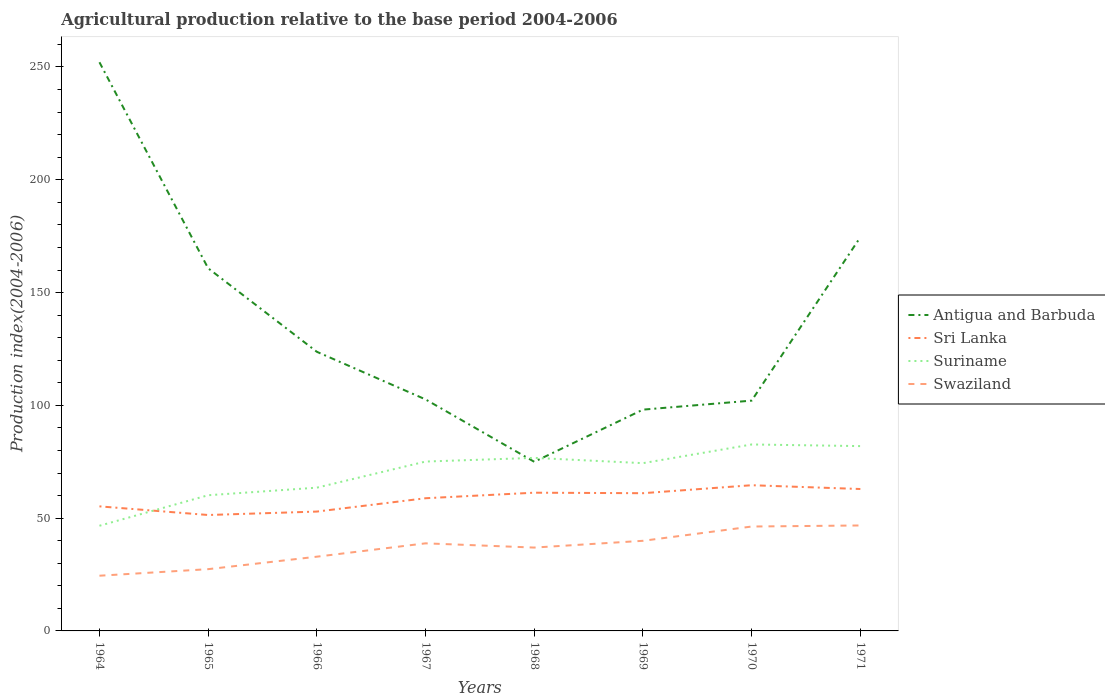Does the line corresponding to Antigua and Barbuda intersect with the line corresponding to Swaziland?
Offer a very short reply. No. Across all years, what is the maximum agricultural production index in Swaziland?
Ensure brevity in your answer.  24.47. In which year was the agricultural production index in Swaziland maximum?
Make the answer very short. 1964. What is the total agricultural production index in Swaziland in the graph?
Provide a succinct answer. -8.44. What is the difference between the highest and the second highest agricultural production index in Sri Lanka?
Make the answer very short. 13.2. What is the difference between the highest and the lowest agricultural production index in Swaziland?
Provide a short and direct response. 5. How many years are there in the graph?
Your answer should be compact. 8. What is the difference between two consecutive major ticks on the Y-axis?
Offer a terse response. 50. Are the values on the major ticks of Y-axis written in scientific E-notation?
Keep it short and to the point. No. Does the graph contain grids?
Your answer should be very brief. No. How many legend labels are there?
Give a very brief answer. 4. What is the title of the graph?
Ensure brevity in your answer.  Agricultural production relative to the base period 2004-2006. Does "Seychelles" appear as one of the legend labels in the graph?
Provide a short and direct response. No. What is the label or title of the X-axis?
Provide a succinct answer. Years. What is the label or title of the Y-axis?
Offer a very short reply. Production index(2004-2006). What is the Production index(2004-2006) of Antigua and Barbuda in 1964?
Keep it short and to the point. 252.1. What is the Production index(2004-2006) of Sri Lanka in 1964?
Your answer should be very brief. 55.22. What is the Production index(2004-2006) in Suriname in 1964?
Keep it short and to the point. 46.62. What is the Production index(2004-2006) of Swaziland in 1964?
Give a very brief answer. 24.47. What is the Production index(2004-2006) in Antigua and Barbuda in 1965?
Offer a terse response. 160.77. What is the Production index(2004-2006) of Sri Lanka in 1965?
Provide a short and direct response. 51.39. What is the Production index(2004-2006) of Suriname in 1965?
Keep it short and to the point. 60.15. What is the Production index(2004-2006) in Swaziland in 1965?
Your answer should be compact. 27.38. What is the Production index(2004-2006) in Antigua and Barbuda in 1966?
Your answer should be compact. 123.74. What is the Production index(2004-2006) in Sri Lanka in 1966?
Your response must be concise. 52.91. What is the Production index(2004-2006) in Suriname in 1966?
Ensure brevity in your answer.  63.51. What is the Production index(2004-2006) of Swaziland in 1966?
Provide a short and direct response. 32.91. What is the Production index(2004-2006) in Antigua and Barbuda in 1967?
Keep it short and to the point. 102.63. What is the Production index(2004-2006) in Sri Lanka in 1967?
Ensure brevity in your answer.  58.82. What is the Production index(2004-2006) in Suriname in 1967?
Your answer should be compact. 75.08. What is the Production index(2004-2006) of Swaziland in 1967?
Offer a terse response. 38.83. What is the Production index(2004-2006) of Antigua and Barbuda in 1968?
Make the answer very short. 74.98. What is the Production index(2004-2006) of Sri Lanka in 1968?
Ensure brevity in your answer.  61.28. What is the Production index(2004-2006) in Suriname in 1968?
Offer a terse response. 76.72. What is the Production index(2004-2006) in Swaziland in 1968?
Provide a short and direct response. 36.95. What is the Production index(2004-2006) of Antigua and Barbuda in 1969?
Provide a succinct answer. 98.1. What is the Production index(2004-2006) of Sri Lanka in 1969?
Offer a terse response. 61.05. What is the Production index(2004-2006) in Suriname in 1969?
Offer a terse response. 74.37. What is the Production index(2004-2006) of Swaziland in 1969?
Provide a short and direct response. 39.95. What is the Production index(2004-2006) of Antigua and Barbuda in 1970?
Provide a succinct answer. 102.1. What is the Production index(2004-2006) of Sri Lanka in 1970?
Give a very brief answer. 64.59. What is the Production index(2004-2006) in Suriname in 1970?
Provide a succinct answer. 82.66. What is the Production index(2004-2006) in Swaziland in 1970?
Keep it short and to the point. 46.28. What is the Production index(2004-2006) in Antigua and Barbuda in 1971?
Ensure brevity in your answer.  174.55. What is the Production index(2004-2006) of Sri Lanka in 1971?
Offer a terse response. 62.91. What is the Production index(2004-2006) in Suriname in 1971?
Your answer should be very brief. 81.93. What is the Production index(2004-2006) in Swaziland in 1971?
Offer a very short reply. 46.75. Across all years, what is the maximum Production index(2004-2006) in Antigua and Barbuda?
Your response must be concise. 252.1. Across all years, what is the maximum Production index(2004-2006) of Sri Lanka?
Provide a succinct answer. 64.59. Across all years, what is the maximum Production index(2004-2006) of Suriname?
Your answer should be compact. 82.66. Across all years, what is the maximum Production index(2004-2006) in Swaziland?
Ensure brevity in your answer.  46.75. Across all years, what is the minimum Production index(2004-2006) of Antigua and Barbuda?
Make the answer very short. 74.98. Across all years, what is the minimum Production index(2004-2006) in Sri Lanka?
Offer a very short reply. 51.39. Across all years, what is the minimum Production index(2004-2006) in Suriname?
Provide a succinct answer. 46.62. Across all years, what is the minimum Production index(2004-2006) of Swaziland?
Offer a very short reply. 24.47. What is the total Production index(2004-2006) of Antigua and Barbuda in the graph?
Ensure brevity in your answer.  1088.97. What is the total Production index(2004-2006) in Sri Lanka in the graph?
Make the answer very short. 468.17. What is the total Production index(2004-2006) in Suriname in the graph?
Make the answer very short. 561.04. What is the total Production index(2004-2006) in Swaziland in the graph?
Your response must be concise. 293.52. What is the difference between the Production index(2004-2006) in Antigua and Barbuda in 1964 and that in 1965?
Give a very brief answer. 91.33. What is the difference between the Production index(2004-2006) of Sri Lanka in 1964 and that in 1965?
Keep it short and to the point. 3.83. What is the difference between the Production index(2004-2006) in Suriname in 1964 and that in 1965?
Provide a succinct answer. -13.53. What is the difference between the Production index(2004-2006) in Swaziland in 1964 and that in 1965?
Your answer should be very brief. -2.91. What is the difference between the Production index(2004-2006) of Antigua and Barbuda in 1964 and that in 1966?
Keep it short and to the point. 128.36. What is the difference between the Production index(2004-2006) in Sri Lanka in 1964 and that in 1966?
Offer a terse response. 2.31. What is the difference between the Production index(2004-2006) in Suriname in 1964 and that in 1966?
Your answer should be compact. -16.89. What is the difference between the Production index(2004-2006) in Swaziland in 1964 and that in 1966?
Your answer should be very brief. -8.44. What is the difference between the Production index(2004-2006) in Antigua and Barbuda in 1964 and that in 1967?
Offer a terse response. 149.47. What is the difference between the Production index(2004-2006) of Sri Lanka in 1964 and that in 1967?
Keep it short and to the point. -3.6. What is the difference between the Production index(2004-2006) of Suriname in 1964 and that in 1967?
Make the answer very short. -28.46. What is the difference between the Production index(2004-2006) of Swaziland in 1964 and that in 1967?
Ensure brevity in your answer.  -14.36. What is the difference between the Production index(2004-2006) in Antigua and Barbuda in 1964 and that in 1968?
Offer a terse response. 177.12. What is the difference between the Production index(2004-2006) of Sri Lanka in 1964 and that in 1968?
Give a very brief answer. -6.06. What is the difference between the Production index(2004-2006) of Suriname in 1964 and that in 1968?
Ensure brevity in your answer.  -30.1. What is the difference between the Production index(2004-2006) of Swaziland in 1964 and that in 1968?
Give a very brief answer. -12.48. What is the difference between the Production index(2004-2006) of Antigua and Barbuda in 1964 and that in 1969?
Keep it short and to the point. 154. What is the difference between the Production index(2004-2006) of Sri Lanka in 1964 and that in 1969?
Your response must be concise. -5.83. What is the difference between the Production index(2004-2006) of Suriname in 1964 and that in 1969?
Your response must be concise. -27.75. What is the difference between the Production index(2004-2006) in Swaziland in 1964 and that in 1969?
Offer a terse response. -15.48. What is the difference between the Production index(2004-2006) of Antigua and Barbuda in 1964 and that in 1970?
Provide a succinct answer. 150. What is the difference between the Production index(2004-2006) of Sri Lanka in 1964 and that in 1970?
Make the answer very short. -9.37. What is the difference between the Production index(2004-2006) in Suriname in 1964 and that in 1970?
Provide a short and direct response. -36.04. What is the difference between the Production index(2004-2006) in Swaziland in 1964 and that in 1970?
Make the answer very short. -21.81. What is the difference between the Production index(2004-2006) of Antigua and Barbuda in 1964 and that in 1971?
Give a very brief answer. 77.55. What is the difference between the Production index(2004-2006) in Sri Lanka in 1964 and that in 1971?
Offer a very short reply. -7.69. What is the difference between the Production index(2004-2006) in Suriname in 1964 and that in 1971?
Your answer should be compact. -35.31. What is the difference between the Production index(2004-2006) of Swaziland in 1964 and that in 1971?
Your response must be concise. -22.28. What is the difference between the Production index(2004-2006) of Antigua and Barbuda in 1965 and that in 1966?
Provide a short and direct response. 37.03. What is the difference between the Production index(2004-2006) in Sri Lanka in 1965 and that in 1966?
Give a very brief answer. -1.52. What is the difference between the Production index(2004-2006) of Suriname in 1965 and that in 1966?
Make the answer very short. -3.36. What is the difference between the Production index(2004-2006) of Swaziland in 1965 and that in 1966?
Keep it short and to the point. -5.53. What is the difference between the Production index(2004-2006) in Antigua and Barbuda in 1965 and that in 1967?
Provide a succinct answer. 58.14. What is the difference between the Production index(2004-2006) of Sri Lanka in 1965 and that in 1967?
Make the answer very short. -7.43. What is the difference between the Production index(2004-2006) in Suriname in 1965 and that in 1967?
Offer a very short reply. -14.93. What is the difference between the Production index(2004-2006) in Swaziland in 1965 and that in 1967?
Make the answer very short. -11.45. What is the difference between the Production index(2004-2006) in Antigua and Barbuda in 1965 and that in 1968?
Your answer should be compact. 85.79. What is the difference between the Production index(2004-2006) in Sri Lanka in 1965 and that in 1968?
Ensure brevity in your answer.  -9.89. What is the difference between the Production index(2004-2006) of Suriname in 1965 and that in 1968?
Make the answer very short. -16.57. What is the difference between the Production index(2004-2006) of Swaziland in 1965 and that in 1968?
Offer a very short reply. -9.57. What is the difference between the Production index(2004-2006) of Antigua and Barbuda in 1965 and that in 1969?
Give a very brief answer. 62.67. What is the difference between the Production index(2004-2006) in Sri Lanka in 1965 and that in 1969?
Your answer should be compact. -9.66. What is the difference between the Production index(2004-2006) in Suriname in 1965 and that in 1969?
Provide a short and direct response. -14.22. What is the difference between the Production index(2004-2006) of Swaziland in 1965 and that in 1969?
Your response must be concise. -12.57. What is the difference between the Production index(2004-2006) in Antigua and Barbuda in 1965 and that in 1970?
Ensure brevity in your answer.  58.67. What is the difference between the Production index(2004-2006) of Sri Lanka in 1965 and that in 1970?
Your answer should be compact. -13.2. What is the difference between the Production index(2004-2006) in Suriname in 1965 and that in 1970?
Your answer should be compact. -22.51. What is the difference between the Production index(2004-2006) of Swaziland in 1965 and that in 1970?
Offer a terse response. -18.9. What is the difference between the Production index(2004-2006) in Antigua and Barbuda in 1965 and that in 1971?
Your answer should be very brief. -13.78. What is the difference between the Production index(2004-2006) of Sri Lanka in 1965 and that in 1971?
Ensure brevity in your answer.  -11.52. What is the difference between the Production index(2004-2006) of Suriname in 1965 and that in 1971?
Offer a very short reply. -21.78. What is the difference between the Production index(2004-2006) of Swaziland in 1965 and that in 1971?
Your response must be concise. -19.37. What is the difference between the Production index(2004-2006) of Antigua and Barbuda in 1966 and that in 1967?
Provide a succinct answer. 21.11. What is the difference between the Production index(2004-2006) of Sri Lanka in 1966 and that in 1967?
Offer a terse response. -5.91. What is the difference between the Production index(2004-2006) of Suriname in 1966 and that in 1967?
Ensure brevity in your answer.  -11.57. What is the difference between the Production index(2004-2006) of Swaziland in 1966 and that in 1967?
Give a very brief answer. -5.92. What is the difference between the Production index(2004-2006) in Antigua and Barbuda in 1966 and that in 1968?
Your response must be concise. 48.76. What is the difference between the Production index(2004-2006) in Sri Lanka in 1966 and that in 1968?
Your answer should be compact. -8.37. What is the difference between the Production index(2004-2006) of Suriname in 1966 and that in 1968?
Make the answer very short. -13.21. What is the difference between the Production index(2004-2006) in Swaziland in 1966 and that in 1968?
Offer a very short reply. -4.04. What is the difference between the Production index(2004-2006) of Antigua and Barbuda in 1966 and that in 1969?
Offer a very short reply. 25.64. What is the difference between the Production index(2004-2006) in Sri Lanka in 1966 and that in 1969?
Make the answer very short. -8.14. What is the difference between the Production index(2004-2006) in Suriname in 1966 and that in 1969?
Provide a short and direct response. -10.86. What is the difference between the Production index(2004-2006) in Swaziland in 1966 and that in 1969?
Offer a terse response. -7.04. What is the difference between the Production index(2004-2006) of Antigua and Barbuda in 1966 and that in 1970?
Ensure brevity in your answer.  21.64. What is the difference between the Production index(2004-2006) in Sri Lanka in 1966 and that in 1970?
Give a very brief answer. -11.68. What is the difference between the Production index(2004-2006) in Suriname in 1966 and that in 1970?
Your answer should be compact. -19.15. What is the difference between the Production index(2004-2006) of Swaziland in 1966 and that in 1970?
Offer a terse response. -13.37. What is the difference between the Production index(2004-2006) of Antigua and Barbuda in 1966 and that in 1971?
Offer a very short reply. -50.81. What is the difference between the Production index(2004-2006) in Sri Lanka in 1966 and that in 1971?
Offer a terse response. -10. What is the difference between the Production index(2004-2006) of Suriname in 1966 and that in 1971?
Your response must be concise. -18.42. What is the difference between the Production index(2004-2006) of Swaziland in 1966 and that in 1971?
Make the answer very short. -13.84. What is the difference between the Production index(2004-2006) in Antigua and Barbuda in 1967 and that in 1968?
Ensure brevity in your answer.  27.65. What is the difference between the Production index(2004-2006) of Sri Lanka in 1967 and that in 1968?
Your answer should be very brief. -2.46. What is the difference between the Production index(2004-2006) of Suriname in 1967 and that in 1968?
Offer a terse response. -1.64. What is the difference between the Production index(2004-2006) of Swaziland in 1967 and that in 1968?
Ensure brevity in your answer.  1.88. What is the difference between the Production index(2004-2006) of Antigua and Barbuda in 1967 and that in 1969?
Your response must be concise. 4.53. What is the difference between the Production index(2004-2006) of Sri Lanka in 1967 and that in 1969?
Your answer should be very brief. -2.23. What is the difference between the Production index(2004-2006) in Suriname in 1967 and that in 1969?
Provide a succinct answer. 0.71. What is the difference between the Production index(2004-2006) in Swaziland in 1967 and that in 1969?
Keep it short and to the point. -1.12. What is the difference between the Production index(2004-2006) of Antigua and Barbuda in 1967 and that in 1970?
Make the answer very short. 0.53. What is the difference between the Production index(2004-2006) in Sri Lanka in 1967 and that in 1970?
Offer a terse response. -5.77. What is the difference between the Production index(2004-2006) of Suriname in 1967 and that in 1970?
Offer a terse response. -7.58. What is the difference between the Production index(2004-2006) in Swaziland in 1967 and that in 1970?
Offer a very short reply. -7.45. What is the difference between the Production index(2004-2006) in Antigua and Barbuda in 1967 and that in 1971?
Offer a very short reply. -71.92. What is the difference between the Production index(2004-2006) in Sri Lanka in 1967 and that in 1971?
Ensure brevity in your answer.  -4.09. What is the difference between the Production index(2004-2006) in Suriname in 1967 and that in 1971?
Your answer should be very brief. -6.85. What is the difference between the Production index(2004-2006) in Swaziland in 1967 and that in 1971?
Give a very brief answer. -7.92. What is the difference between the Production index(2004-2006) of Antigua and Barbuda in 1968 and that in 1969?
Provide a succinct answer. -23.12. What is the difference between the Production index(2004-2006) of Sri Lanka in 1968 and that in 1969?
Your answer should be very brief. 0.23. What is the difference between the Production index(2004-2006) in Suriname in 1968 and that in 1969?
Give a very brief answer. 2.35. What is the difference between the Production index(2004-2006) of Antigua and Barbuda in 1968 and that in 1970?
Your answer should be very brief. -27.12. What is the difference between the Production index(2004-2006) in Sri Lanka in 1968 and that in 1970?
Ensure brevity in your answer.  -3.31. What is the difference between the Production index(2004-2006) of Suriname in 1968 and that in 1970?
Your answer should be compact. -5.94. What is the difference between the Production index(2004-2006) of Swaziland in 1968 and that in 1970?
Offer a terse response. -9.33. What is the difference between the Production index(2004-2006) of Antigua and Barbuda in 1968 and that in 1971?
Your answer should be very brief. -99.57. What is the difference between the Production index(2004-2006) in Sri Lanka in 1968 and that in 1971?
Your response must be concise. -1.63. What is the difference between the Production index(2004-2006) of Suriname in 1968 and that in 1971?
Your answer should be compact. -5.21. What is the difference between the Production index(2004-2006) in Antigua and Barbuda in 1969 and that in 1970?
Provide a succinct answer. -4. What is the difference between the Production index(2004-2006) of Sri Lanka in 1969 and that in 1970?
Make the answer very short. -3.54. What is the difference between the Production index(2004-2006) in Suriname in 1969 and that in 1970?
Make the answer very short. -8.29. What is the difference between the Production index(2004-2006) in Swaziland in 1969 and that in 1970?
Make the answer very short. -6.33. What is the difference between the Production index(2004-2006) in Antigua and Barbuda in 1969 and that in 1971?
Offer a very short reply. -76.45. What is the difference between the Production index(2004-2006) in Sri Lanka in 1969 and that in 1971?
Provide a succinct answer. -1.86. What is the difference between the Production index(2004-2006) of Suriname in 1969 and that in 1971?
Keep it short and to the point. -7.56. What is the difference between the Production index(2004-2006) in Swaziland in 1969 and that in 1971?
Your answer should be very brief. -6.8. What is the difference between the Production index(2004-2006) of Antigua and Barbuda in 1970 and that in 1971?
Keep it short and to the point. -72.45. What is the difference between the Production index(2004-2006) in Sri Lanka in 1970 and that in 1971?
Offer a terse response. 1.68. What is the difference between the Production index(2004-2006) in Suriname in 1970 and that in 1971?
Give a very brief answer. 0.73. What is the difference between the Production index(2004-2006) in Swaziland in 1970 and that in 1971?
Offer a terse response. -0.47. What is the difference between the Production index(2004-2006) of Antigua and Barbuda in 1964 and the Production index(2004-2006) of Sri Lanka in 1965?
Ensure brevity in your answer.  200.71. What is the difference between the Production index(2004-2006) in Antigua and Barbuda in 1964 and the Production index(2004-2006) in Suriname in 1965?
Ensure brevity in your answer.  191.95. What is the difference between the Production index(2004-2006) of Antigua and Barbuda in 1964 and the Production index(2004-2006) of Swaziland in 1965?
Your answer should be compact. 224.72. What is the difference between the Production index(2004-2006) of Sri Lanka in 1964 and the Production index(2004-2006) of Suriname in 1965?
Give a very brief answer. -4.93. What is the difference between the Production index(2004-2006) in Sri Lanka in 1964 and the Production index(2004-2006) in Swaziland in 1965?
Your answer should be compact. 27.84. What is the difference between the Production index(2004-2006) of Suriname in 1964 and the Production index(2004-2006) of Swaziland in 1965?
Provide a short and direct response. 19.24. What is the difference between the Production index(2004-2006) in Antigua and Barbuda in 1964 and the Production index(2004-2006) in Sri Lanka in 1966?
Ensure brevity in your answer.  199.19. What is the difference between the Production index(2004-2006) in Antigua and Barbuda in 1964 and the Production index(2004-2006) in Suriname in 1966?
Your response must be concise. 188.59. What is the difference between the Production index(2004-2006) of Antigua and Barbuda in 1964 and the Production index(2004-2006) of Swaziland in 1966?
Your answer should be very brief. 219.19. What is the difference between the Production index(2004-2006) of Sri Lanka in 1964 and the Production index(2004-2006) of Suriname in 1966?
Ensure brevity in your answer.  -8.29. What is the difference between the Production index(2004-2006) of Sri Lanka in 1964 and the Production index(2004-2006) of Swaziland in 1966?
Ensure brevity in your answer.  22.31. What is the difference between the Production index(2004-2006) in Suriname in 1964 and the Production index(2004-2006) in Swaziland in 1966?
Offer a terse response. 13.71. What is the difference between the Production index(2004-2006) in Antigua and Barbuda in 1964 and the Production index(2004-2006) in Sri Lanka in 1967?
Your response must be concise. 193.28. What is the difference between the Production index(2004-2006) in Antigua and Barbuda in 1964 and the Production index(2004-2006) in Suriname in 1967?
Give a very brief answer. 177.02. What is the difference between the Production index(2004-2006) of Antigua and Barbuda in 1964 and the Production index(2004-2006) of Swaziland in 1967?
Your answer should be compact. 213.27. What is the difference between the Production index(2004-2006) in Sri Lanka in 1964 and the Production index(2004-2006) in Suriname in 1967?
Your answer should be very brief. -19.86. What is the difference between the Production index(2004-2006) of Sri Lanka in 1964 and the Production index(2004-2006) of Swaziland in 1967?
Make the answer very short. 16.39. What is the difference between the Production index(2004-2006) of Suriname in 1964 and the Production index(2004-2006) of Swaziland in 1967?
Ensure brevity in your answer.  7.79. What is the difference between the Production index(2004-2006) of Antigua and Barbuda in 1964 and the Production index(2004-2006) of Sri Lanka in 1968?
Provide a short and direct response. 190.82. What is the difference between the Production index(2004-2006) in Antigua and Barbuda in 1964 and the Production index(2004-2006) in Suriname in 1968?
Give a very brief answer. 175.38. What is the difference between the Production index(2004-2006) of Antigua and Barbuda in 1964 and the Production index(2004-2006) of Swaziland in 1968?
Make the answer very short. 215.15. What is the difference between the Production index(2004-2006) of Sri Lanka in 1964 and the Production index(2004-2006) of Suriname in 1968?
Your answer should be very brief. -21.5. What is the difference between the Production index(2004-2006) of Sri Lanka in 1964 and the Production index(2004-2006) of Swaziland in 1968?
Provide a succinct answer. 18.27. What is the difference between the Production index(2004-2006) of Suriname in 1964 and the Production index(2004-2006) of Swaziland in 1968?
Keep it short and to the point. 9.67. What is the difference between the Production index(2004-2006) in Antigua and Barbuda in 1964 and the Production index(2004-2006) in Sri Lanka in 1969?
Your answer should be very brief. 191.05. What is the difference between the Production index(2004-2006) of Antigua and Barbuda in 1964 and the Production index(2004-2006) of Suriname in 1969?
Keep it short and to the point. 177.73. What is the difference between the Production index(2004-2006) of Antigua and Barbuda in 1964 and the Production index(2004-2006) of Swaziland in 1969?
Your answer should be very brief. 212.15. What is the difference between the Production index(2004-2006) of Sri Lanka in 1964 and the Production index(2004-2006) of Suriname in 1969?
Offer a very short reply. -19.15. What is the difference between the Production index(2004-2006) in Sri Lanka in 1964 and the Production index(2004-2006) in Swaziland in 1969?
Your answer should be very brief. 15.27. What is the difference between the Production index(2004-2006) in Suriname in 1964 and the Production index(2004-2006) in Swaziland in 1969?
Your answer should be compact. 6.67. What is the difference between the Production index(2004-2006) of Antigua and Barbuda in 1964 and the Production index(2004-2006) of Sri Lanka in 1970?
Your answer should be compact. 187.51. What is the difference between the Production index(2004-2006) in Antigua and Barbuda in 1964 and the Production index(2004-2006) in Suriname in 1970?
Make the answer very short. 169.44. What is the difference between the Production index(2004-2006) in Antigua and Barbuda in 1964 and the Production index(2004-2006) in Swaziland in 1970?
Keep it short and to the point. 205.82. What is the difference between the Production index(2004-2006) in Sri Lanka in 1964 and the Production index(2004-2006) in Suriname in 1970?
Make the answer very short. -27.44. What is the difference between the Production index(2004-2006) of Sri Lanka in 1964 and the Production index(2004-2006) of Swaziland in 1970?
Give a very brief answer. 8.94. What is the difference between the Production index(2004-2006) of Suriname in 1964 and the Production index(2004-2006) of Swaziland in 1970?
Ensure brevity in your answer.  0.34. What is the difference between the Production index(2004-2006) in Antigua and Barbuda in 1964 and the Production index(2004-2006) in Sri Lanka in 1971?
Keep it short and to the point. 189.19. What is the difference between the Production index(2004-2006) of Antigua and Barbuda in 1964 and the Production index(2004-2006) of Suriname in 1971?
Make the answer very short. 170.17. What is the difference between the Production index(2004-2006) of Antigua and Barbuda in 1964 and the Production index(2004-2006) of Swaziland in 1971?
Ensure brevity in your answer.  205.35. What is the difference between the Production index(2004-2006) in Sri Lanka in 1964 and the Production index(2004-2006) in Suriname in 1971?
Provide a short and direct response. -26.71. What is the difference between the Production index(2004-2006) in Sri Lanka in 1964 and the Production index(2004-2006) in Swaziland in 1971?
Your answer should be very brief. 8.47. What is the difference between the Production index(2004-2006) in Suriname in 1964 and the Production index(2004-2006) in Swaziland in 1971?
Make the answer very short. -0.13. What is the difference between the Production index(2004-2006) of Antigua and Barbuda in 1965 and the Production index(2004-2006) of Sri Lanka in 1966?
Give a very brief answer. 107.86. What is the difference between the Production index(2004-2006) in Antigua and Barbuda in 1965 and the Production index(2004-2006) in Suriname in 1966?
Give a very brief answer. 97.26. What is the difference between the Production index(2004-2006) in Antigua and Barbuda in 1965 and the Production index(2004-2006) in Swaziland in 1966?
Provide a succinct answer. 127.86. What is the difference between the Production index(2004-2006) in Sri Lanka in 1965 and the Production index(2004-2006) in Suriname in 1966?
Provide a succinct answer. -12.12. What is the difference between the Production index(2004-2006) of Sri Lanka in 1965 and the Production index(2004-2006) of Swaziland in 1966?
Provide a succinct answer. 18.48. What is the difference between the Production index(2004-2006) in Suriname in 1965 and the Production index(2004-2006) in Swaziland in 1966?
Your response must be concise. 27.24. What is the difference between the Production index(2004-2006) of Antigua and Barbuda in 1965 and the Production index(2004-2006) of Sri Lanka in 1967?
Keep it short and to the point. 101.95. What is the difference between the Production index(2004-2006) in Antigua and Barbuda in 1965 and the Production index(2004-2006) in Suriname in 1967?
Your answer should be very brief. 85.69. What is the difference between the Production index(2004-2006) in Antigua and Barbuda in 1965 and the Production index(2004-2006) in Swaziland in 1967?
Ensure brevity in your answer.  121.94. What is the difference between the Production index(2004-2006) in Sri Lanka in 1965 and the Production index(2004-2006) in Suriname in 1967?
Your answer should be very brief. -23.69. What is the difference between the Production index(2004-2006) in Sri Lanka in 1965 and the Production index(2004-2006) in Swaziland in 1967?
Ensure brevity in your answer.  12.56. What is the difference between the Production index(2004-2006) of Suriname in 1965 and the Production index(2004-2006) of Swaziland in 1967?
Offer a terse response. 21.32. What is the difference between the Production index(2004-2006) of Antigua and Barbuda in 1965 and the Production index(2004-2006) of Sri Lanka in 1968?
Make the answer very short. 99.49. What is the difference between the Production index(2004-2006) in Antigua and Barbuda in 1965 and the Production index(2004-2006) in Suriname in 1968?
Provide a succinct answer. 84.05. What is the difference between the Production index(2004-2006) of Antigua and Barbuda in 1965 and the Production index(2004-2006) of Swaziland in 1968?
Offer a very short reply. 123.82. What is the difference between the Production index(2004-2006) of Sri Lanka in 1965 and the Production index(2004-2006) of Suriname in 1968?
Your response must be concise. -25.33. What is the difference between the Production index(2004-2006) of Sri Lanka in 1965 and the Production index(2004-2006) of Swaziland in 1968?
Your response must be concise. 14.44. What is the difference between the Production index(2004-2006) in Suriname in 1965 and the Production index(2004-2006) in Swaziland in 1968?
Your response must be concise. 23.2. What is the difference between the Production index(2004-2006) in Antigua and Barbuda in 1965 and the Production index(2004-2006) in Sri Lanka in 1969?
Your response must be concise. 99.72. What is the difference between the Production index(2004-2006) of Antigua and Barbuda in 1965 and the Production index(2004-2006) of Suriname in 1969?
Provide a succinct answer. 86.4. What is the difference between the Production index(2004-2006) in Antigua and Barbuda in 1965 and the Production index(2004-2006) in Swaziland in 1969?
Keep it short and to the point. 120.82. What is the difference between the Production index(2004-2006) in Sri Lanka in 1965 and the Production index(2004-2006) in Suriname in 1969?
Your answer should be compact. -22.98. What is the difference between the Production index(2004-2006) of Sri Lanka in 1965 and the Production index(2004-2006) of Swaziland in 1969?
Your answer should be very brief. 11.44. What is the difference between the Production index(2004-2006) of Suriname in 1965 and the Production index(2004-2006) of Swaziland in 1969?
Your response must be concise. 20.2. What is the difference between the Production index(2004-2006) in Antigua and Barbuda in 1965 and the Production index(2004-2006) in Sri Lanka in 1970?
Offer a very short reply. 96.18. What is the difference between the Production index(2004-2006) in Antigua and Barbuda in 1965 and the Production index(2004-2006) in Suriname in 1970?
Provide a short and direct response. 78.11. What is the difference between the Production index(2004-2006) of Antigua and Barbuda in 1965 and the Production index(2004-2006) of Swaziland in 1970?
Offer a very short reply. 114.49. What is the difference between the Production index(2004-2006) in Sri Lanka in 1965 and the Production index(2004-2006) in Suriname in 1970?
Provide a succinct answer. -31.27. What is the difference between the Production index(2004-2006) in Sri Lanka in 1965 and the Production index(2004-2006) in Swaziland in 1970?
Offer a very short reply. 5.11. What is the difference between the Production index(2004-2006) in Suriname in 1965 and the Production index(2004-2006) in Swaziland in 1970?
Ensure brevity in your answer.  13.87. What is the difference between the Production index(2004-2006) of Antigua and Barbuda in 1965 and the Production index(2004-2006) of Sri Lanka in 1971?
Your response must be concise. 97.86. What is the difference between the Production index(2004-2006) in Antigua and Barbuda in 1965 and the Production index(2004-2006) in Suriname in 1971?
Make the answer very short. 78.84. What is the difference between the Production index(2004-2006) of Antigua and Barbuda in 1965 and the Production index(2004-2006) of Swaziland in 1971?
Provide a short and direct response. 114.02. What is the difference between the Production index(2004-2006) in Sri Lanka in 1965 and the Production index(2004-2006) in Suriname in 1971?
Make the answer very short. -30.54. What is the difference between the Production index(2004-2006) of Sri Lanka in 1965 and the Production index(2004-2006) of Swaziland in 1971?
Give a very brief answer. 4.64. What is the difference between the Production index(2004-2006) in Suriname in 1965 and the Production index(2004-2006) in Swaziland in 1971?
Give a very brief answer. 13.4. What is the difference between the Production index(2004-2006) of Antigua and Barbuda in 1966 and the Production index(2004-2006) of Sri Lanka in 1967?
Offer a terse response. 64.92. What is the difference between the Production index(2004-2006) of Antigua and Barbuda in 1966 and the Production index(2004-2006) of Suriname in 1967?
Offer a terse response. 48.66. What is the difference between the Production index(2004-2006) in Antigua and Barbuda in 1966 and the Production index(2004-2006) in Swaziland in 1967?
Keep it short and to the point. 84.91. What is the difference between the Production index(2004-2006) in Sri Lanka in 1966 and the Production index(2004-2006) in Suriname in 1967?
Keep it short and to the point. -22.17. What is the difference between the Production index(2004-2006) of Sri Lanka in 1966 and the Production index(2004-2006) of Swaziland in 1967?
Give a very brief answer. 14.08. What is the difference between the Production index(2004-2006) of Suriname in 1966 and the Production index(2004-2006) of Swaziland in 1967?
Provide a succinct answer. 24.68. What is the difference between the Production index(2004-2006) in Antigua and Barbuda in 1966 and the Production index(2004-2006) in Sri Lanka in 1968?
Offer a terse response. 62.46. What is the difference between the Production index(2004-2006) of Antigua and Barbuda in 1966 and the Production index(2004-2006) of Suriname in 1968?
Your answer should be compact. 47.02. What is the difference between the Production index(2004-2006) of Antigua and Barbuda in 1966 and the Production index(2004-2006) of Swaziland in 1968?
Make the answer very short. 86.79. What is the difference between the Production index(2004-2006) in Sri Lanka in 1966 and the Production index(2004-2006) in Suriname in 1968?
Your answer should be very brief. -23.81. What is the difference between the Production index(2004-2006) in Sri Lanka in 1966 and the Production index(2004-2006) in Swaziland in 1968?
Your answer should be compact. 15.96. What is the difference between the Production index(2004-2006) of Suriname in 1966 and the Production index(2004-2006) of Swaziland in 1968?
Provide a short and direct response. 26.56. What is the difference between the Production index(2004-2006) of Antigua and Barbuda in 1966 and the Production index(2004-2006) of Sri Lanka in 1969?
Give a very brief answer. 62.69. What is the difference between the Production index(2004-2006) of Antigua and Barbuda in 1966 and the Production index(2004-2006) of Suriname in 1969?
Provide a succinct answer. 49.37. What is the difference between the Production index(2004-2006) of Antigua and Barbuda in 1966 and the Production index(2004-2006) of Swaziland in 1969?
Provide a short and direct response. 83.79. What is the difference between the Production index(2004-2006) in Sri Lanka in 1966 and the Production index(2004-2006) in Suriname in 1969?
Your response must be concise. -21.46. What is the difference between the Production index(2004-2006) in Sri Lanka in 1966 and the Production index(2004-2006) in Swaziland in 1969?
Offer a very short reply. 12.96. What is the difference between the Production index(2004-2006) in Suriname in 1966 and the Production index(2004-2006) in Swaziland in 1969?
Offer a terse response. 23.56. What is the difference between the Production index(2004-2006) of Antigua and Barbuda in 1966 and the Production index(2004-2006) of Sri Lanka in 1970?
Your response must be concise. 59.15. What is the difference between the Production index(2004-2006) in Antigua and Barbuda in 1966 and the Production index(2004-2006) in Suriname in 1970?
Provide a succinct answer. 41.08. What is the difference between the Production index(2004-2006) of Antigua and Barbuda in 1966 and the Production index(2004-2006) of Swaziland in 1970?
Ensure brevity in your answer.  77.46. What is the difference between the Production index(2004-2006) of Sri Lanka in 1966 and the Production index(2004-2006) of Suriname in 1970?
Offer a terse response. -29.75. What is the difference between the Production index(2004-2006) in Sri Lanka in 1966 and the Production index(2004-2006) in Swaziland in 1970?
Provide a short and direct response. 6.63. What is the difference between the Production index(2004-2006) in Suriname in 1966 and the Production index(2004-2006) in Swaziland in 1970?
Your answer should be compact. 17.23. What is the difference between the Production index(2004-2006) of Antigua and Barbuda in 1966 and the Production index(2004-2006) of Sri Lanka in 1971?
Offer a very short reply. 60.83. What is the difference between the Production index(2004-2006) of Antigua and Barbuda in 1966 and the Production index(2004-2006) of Suriname in 1971?
Keep it short and to the point. 41.81. What is the difference between the Production index(2004-2006) in Antigua and Barbuda in 1966 and the Production index(2004-2006) in Swaziland in 1971?
Ensure brevity in your answer.  76.99. What is the difference between the Production index(2004-2006) of Sri Lanka in 1966 and the Production index(2004-2006) of Suriname in 1971?
Offer a terse response. -29.02. What is the difference between the Production index(2004-2006) in Sri Lanka in 1966 and the Production index(2004-2006) in Swaziland in 1971?
Make the answer very short. 6.16. What is the difference between the Production index(2004-2006) of Suriname in 1966 and the Production index(2004-2006) of Swaziland in 1971?
Provide a succinct answer. 16.76. What is the difference between the Production index(2004-2006) of Antigua and Barbuda in 1967 and the Production index(2004-2006) of Sri Lanka in 1968?
Provide a short and direct response. 41.35. What is the difference between the Production index(2004-2006) of Antigua and Barbuda in 1967 and the Production index(2004-2006) of Suriname in 1968?
Provide a succinct answer. 25.91. What is the difference between the Production index(2004-2006) in Antigua and Barbuda in 1967 and the Production index(2004-2006) in Swaziland in 1968?
Give a very brief answer. 65.68. What is the difference between the Production index(2004-2006) in Sri Lanka in 1967 and the Production index(2004-2006) in Suriname in 1968?
Make the answer very short. -17.9. What is the difference between the Production index(2004-2006) of Sri Lanka in 1967 and the Production index(2004-2006) of Swaziland in 1968?
Your answer should be compact. 21.87. What is the difference between the Production index(2004-2006) of Suriname in 1967 and the Production index(2004-2006) of Swaziland in 1968?
Give a very brief answer. 38.13. What is the difference between the Production index(2004-2006) of Antigua and Barbuda in 1967 and the Production index(2004-2006) of Sri Lanka in 1969?
Ensure brevity in your answer.  41.58. What is the difference between the Production index(2004-2006) of Antigua and Barbuda in 1967 and the Production index(2004-2006) of Suriname in 1969?
Provide a succinct answer. 28.26. What is the difference between the Production index(2004-2006) of Antigua and Barbuda in 1967 and the Production index(2004-2006) of Swaziland in 1969?
Offer a terse response. 62.68. What is the difference between the Production index(2004-2006) in Sri Lanka in 1967 and the Production index(2004-2006) in Suriname in 1969?
Give a very brief answer. -15.55. What is the difference between the Production index(2004-2006) of Sri Lanka in 1967 and the Production index(2004-2006) of Swaziland in 1969?
Offer a terse response. 18.87. What is the difference between the Production index(2004-2006) in Suriname in 1967 and the Production index(2004-2006) in Swaziland in 1969?
Provide a succinct answer. 35.13. What is the difference between the Production index(2004-2006) of Antigua and Barbuda in 1967 and the Production index(2004-2006) of Sri Lanka in 1970?
Your answer should be very brief. 38.04. What is the difference between the Production index(2004-2006) in Antigua and Barbuda in 1967 and the Production index(2004-2006) in Suriname in 1970?
Offer a terse response. 19.97. What is the difference between the Production index(2004-2006) of Antigua and Barbuda in 1967 and the Production index(2004-2006) of Swaziland in 1970?
Make the answer very short. 56.35. What is the difference between the Production index(2004-2006) of Sri Lanka in 1967 and the Production index(2004-2006) of Suriname in 1970?
Ensure brevity in your answer.  -23.84. What is the difference between the Production index(2004-2006) in Sri Lanka in 1967 and the Production index(2004-2006) in Swaziland in 1970?
Offer a very short reply. 12.54. What is the difference between the Production index(2004-2006) in Suriname in 1967 and the Production index(2004-2006) in Swaziland in 1970?
Give a very brief answer. 28.8. What is the difference between the Production index(2004-2006) in Antigua and Barbuda in 1967 and the Production index(2004-2006) in Sri Lanka in 1971?
Provide a succinct answer. 39.72. What is the difference between the Production index(2004-2006) of Antigua and Barbuda in 1967 and the Production index(2004-2006) of Suriname in 1971?
Your answer should be very brief. 20.7. What is the difference between the Production index(2004-2006) in Antigua and Barbuda in 1967 and the Production index(2004-2006) in Swaziland in 1971?
Keep it short and to the point. 55.88. What is the difference between the Production index(2004-2006) in Sri Lanka in 1967 and the Production index(2004-2006) in Suriname in 1971?
Your response must be concise. -23.11. What is the difference between the Production index(2004-2006) of Sri Lanka in 1967 and the Production index(2004-2006) of Swaziland in 1971?
Your answer should be compact. 12.07. What is the difference between the Production index(2004-2006) of Suriname in 1967 and the Production index(2004-2006) of Swaziland in 1971?
Offer a terse response. 28.33. What is the difference between the Production index(2004-2006) in Antigua and Barbuda in 1968 and the Production index(2004-2006) in Sri Lanka in 1969?
Make the answer very short. 13.93. What is the difference between the Production index(2004-2006) in Antigua and Barbuda in 1968 and the Production index(2004-2006) in Suriname in 1969?
Your response must be concise. 0.61. What is the difference between the Production index(2004-2006) in Antigua and Barbuda in 1968 and the Production index(2004-2006) in Swaziland in 1969?
Your answer should be compact. 35.03. What is the difference between the Production index(2004-2006) in Sri Lanka in 1968 and the Production index(2004-2006) in Suriname in 1969?
Your answer should be compact. -13.09. What is the difference between the Production index(2004-2006) in Sri Lanka in 1968 and the Production index(2004-2006) in Swaziland in 1969?
Make the answer very short. 21.33. What is the difference between the Production index(2004-2006) in Suriname in 1968 and the Production index(2004-2006) in Swaziland in 1969?
Provide a short and direct response. 36.77. What is the difference between the Production index(2004-2006) in Antigua and Barbuda in 1968 and the Production index(2004-2006) in Sri Lanka in 1970?
Your answer should be compact. 10.39. What is the difference between the Production index(2004-2006) in Antigua and Barbuda in 1968 and the Production index(2004-2006) in Suriname in 1970?
Provide a short and direct response. -7.68. What is the difference between the Production index(2004-2006) in Antigua and Barbuda in 1968 and the Production index(2004-2006) in Swaziland in 1970?
Ensure brevity in your answer.  28.7. What is the difference between the Production index(2004-2006) of Sri Lanka in 1968 and the Production index(2004-2006) of Suriname in 1970?
Your response must be concise. -21.38. What is the difference between the Production index(2004-2006) of Suriname in 1968 and the Production index(2004-2006) of Swaziland in 1970?
Give a very brief answer. 30.44. What is the difference between the Production index(2004-2006) in Antigua and Barbuda in 1968 and the Production index(2004-2006) in Sri Lanka in 1971?
Make the answer very short. 12.07. What is the difference between the Production index(2004-2006) in Antigua and Barbuda in 1968 and the Production index(2004-2006) in Suriname in 1971?
Ensure brevity in your answer.  -6.95. What is the difference between the Production index(2004-2006) in Antigua and Barbuda in 1968 and the Production index(2004-2006) in Swaziland in 1971?
Offer a very short reply. 28.23. What is the difference between the Production index(2004-2006) of Sri Lanka in 1968 and the Production index(2004-2006) of Suriname in 1971?
Provide a succinct answer. -20.65. What is the difference between the Production index(2004-2006) of Sri Lanka in 1968 and the Production index(2004-2006) of Swaziland in 1971?
Your response must be concise. 14.53. What is the difference between the Production index(2004-2006) of Suriname in 1968 and the Production index(2004-2006) of Swaziland in 1971?
Offer a very short reply. 29.97. What is the difference between the Production index(2004-2006) of Antigua and Barbuda in 1969 and the Production index(2004-2006) of Sri Lanka in 1970?
Offer a very short reply. 33.51. What is the difference between the Production index(2004-2006) of Antigua and Barbuda in 1969 and the Production index(2004-2006) of Suriname in 1970?
Your response must be concise. 15.44. What is the difference between the Production index(2004-2006) of Antigua and Barbuda in 1969 and the Production index(2004-2006) of Swaziland in 1970?
Provide a succinct answer. 51.82. What is the difference between the Production index(2004-2006) of Sri Lanka in 1969 and the Production index(2004-2006) of Suriname in 1970?
Provide a short and direct response. -21.61. What is the difference between the Production index(2004-2006) in Sri Lanka in 1969 and the Production index(2004-2006) in Swaziland in 1970?
Provide a short and direct response. 14.77. What is the difference between the Production index(2004-2006) of Suriname in 1969 and the Production index(2004-2006) of Swaziland in 1970?
Your answer should be compact. 28.09. What is the difference between the Production index(2004-2006) in Antigua and Barbuda in 1969 and the Production index(2004-2006) in Sri Lanka in 1971?
Offer a very short reply. 35.19. What is the difference between the Production index(2004-2006) of Antigua and Barbuda in 1969 and the Production index(2004-2006) of Suriname in 1971?
Keep it short and to the point. 16.17. What is the difference between the Production index(2004-2006) of Antigua and Barbuda in 1969 and the Production index(2004-2006) of Swaziland in 1971?
Give a very brief answer. 51.35. What is the difference between the Production index(2004-2006) of Sri Lanka in 1969 and the Production index(2004-2006) of Suriname in 1971?
Offer a very short reply. -20.88. What is the difference between the Production index(2004-2006) in Sri Lanka in 1969 and the Production index(2004-2006) in Swaziland in 1971?
Provide a succinct answer. 14.3. What is the difference between the Production index(2004-2006) in Suriname in 1969 and the Production index(2004-2006) in Swaziland in 1971?
Provide a succinct answer. 27.62. What is the difference between the Production index(2004-2006) of Antigua and Barbuda in 1970 and the Production index(2004-2006) of Sri Lanka in 1971?
Give a very brief answer. 39.19. What is the difference between the Production index(2004-2006) in Antigua and Barbuda in 1970 and the Production index(2004-2006) in Suriname in 1971?
Keep it short and to the point. 20.17. What is the difference between the Production index(2004-2006) in Antigua and Barbuda in 1970 and the Production index(2004-2006) in Swaziland in 1971?
Ensure brevity in your answer.  55.35. What is the difference between the Production index(2004-2006) in Sri Lanka in 1970 and the Production index(2004-2006) in Suriname in 1971?
Your response must be concise. -17.34. What is the difference between the Production index(2004-2006) in Sri Lanka in 1970 and the Production index(2004-2006) in Swaziland in 1971?
Keep it short and to the point. 17.84. What is the difference between the Production index(2004-2006) in Suriname in 1970 and the Production index(2004-2006) in Swaziland in 1971?
Provide a short and direct response. 35.91. What is the average Production index(2004-2006) in Antigua and Barbuda per year?
Your answer should be compact. 136.12. What is the average Production index(2004-2006) of Sri Lanka per year?
Offer a terse response. 58.52. What is the average Production index(2004-2006) in Suriname per year?
Ensure brevity in your answer.  70.13. What is the average Production index(2004-2006) in Swaziland per year?
Keep it short and to the point. 36.69. In the year 1964, what is the difference between the Production index(2004-2006) of Antigua and Barbuda and Production index(2004-2006) of Sri Lanka?
Make the answer very short. 196.88. In the year 1964, what is the difference between the Production index(2004-2006) of Antigua and Barbuda and Production index(2004-2006) of Suriname?
Your answer should be compact. 205.48. In the year 1964, what is the difference between the Production index(2004-2006) in Antigua and Barbuda and Production index(2004-2006) in Swaziland?
Offer a very short reply. 227.63. In the year 1964, what is the difference between the Production index(2004-2006) of Sri Lanka and Production index(2004-2006) of Swaziland?
Make the answer very short. 30.75. In the year 1964, what is the difference between the Production index(2004-2006) of Suriname and Production index(2004-2006) of Swaziland?
Make the answer very short. 22.15. In the year 1965, what is the difference between the Production index(2004-2006) of Antigua and Barbuda and Production index(2004-2006) of Sri Lanka?
Ensure brevity in your answer.  109.38. In the year 1965, what is the difference between the Production index(2004-2006) of Antigua and Barbuda and Production index(2004-2006) of Suriname?
Your response must be concise. 100.62. In the year 1965, what is the difference between the Production index(2004-2006) of Antigua and Barbuda and Production index(2004-2006) of Swaziland?
Give a very brief answer. 133.39. In the year 1965, what is the difference between the Production index(2004-2006) in Sri Lanka and Production index(2004-2006) in Suriname?
Keep it short and to the point. -8.76. In the year 1965, what is the difference between the Production index(2004-2006) in Sri Lanka and Production index(2004-2006) in Swaziland?
Provide a succinct answer. 24.01. In the year 1965, what is the difference between the Production index(2004-2006) of Suriname and Production index(2004-2006) of Swaziland?
Give a very brief answer. 32.77. In the year 1966, what is the difference between the Production index(2004-2006) in Antigua and Barbuda and Production index(2004-2006) in Sri Lanka?
Make the answer very short. 70.83. In the year 1966, what is the difference between the Production index(2004-2006) in Antigua and Barbuda and Production index(2004-2006) in Suriname?
Make the answer very short. 60.23. In the year 1966, what is the difference between the Production index(2004-2006) in Antigua and Barbuda and Production index(2004-2006) in Swaziland?
Offer a terse response. 90.83. In the year 1966, what is the difference between the Production index(2004-2006) in Sri Lanka and Production index(2004-2006) in Suriname?
Ensure brevity in your answer.  -10.6. In the year 1966, what is the difference between the Production index(2004-2006) in Suriname and Production index(2004-2006) in Swaziland?
Keep it short and to the point. 30.6. In the year 1967, what is the difference between the Production index(2004-2006) of Antigua and Barbuda and Production index(2004-2006) of Sri Lanka?
Your answer should be very brief. 43.81. In the year 1967, what is the difference between the Production index(2004-2006) of Antigua and Barbuda and Production index(2004-2006) of Suriname?
Offer a very short reply. 27.55. In the year 1967, what is the difference between the Production index(2004-2006) in Antigua and Barbuda and Production index(2004-2006) in Swaziland?
Your answer should be compact. 63.8. In the year 1967, what is the difference between the Production index(2004-2006) in Sri Lanka and Production index(2004-2006) in Suriname?
Your answer should be compact. -16.26. In the year 1967, what is the difference between the Production index(2004-2006) in Sri Lanka and Production index(2004-2006) in Swaziland?
Keep it short and to the point. 19.99. In the year 1967, what is the difference between the Production index(2004-2006) in Suriname and Production index(2004-2006) in Swaziland?
Your answer should be compact. 36.25. In the year 1968, what is the difference between the Production index(2004-2006) in Antigua and Barbuda and Production index(2004-2006) in Sri Lanka?
Offer a very short reply. 13.7. In the year 1968, what is the difference between the Production index(2004-2006) of Antigua and Barbuda and Production index(2004-2006) of Suriname?
Your answer should be very brief. -1.74. In the year 1968, what is the difference between the Production index(2004-2006) of Antigua and Barbuda and Production index(2004-2006) of Swaziland?
Offer a very short reply. 38.03. In the year 1968, what is the difference between the Production index(2004-2006) in Sri Lanka and Production index(2004-2006) in Suriname?
Provide a succinct answer. -15.44. In the year 1968, what is the difference between the Production index(2004-2006) of Sri Lanka and Production index(2004-2006) of Swaziland?
Give a very brief answer. 24.33. In the year 1968, what is the difference between the Production index(2004-2006) of Suriname and Production index(2004-2006) of Swaziland?
Your answer should be very brief. 39.77. In the year 1969, what is the difference between the Production index(2004-2006) in Antigua and Barbuda and Production index(2004-2006) in Sri Lanka?
Offer a terse response. 37.05. In the year 1969, what is the difference between the Production index(2004-2006) in Antigua and Barbuda and Production index(2004-2006) in Suriname?
Your answer should be very brief. 23.73. In the year 1969, what is the difference between the Production index(2004-2006) in Antigua and Barbuda and Production index(2004-2006) in Swaziland?
Your answer should be compact. 58.15. In the year 1969, what is the difference between the Production index(2004-2006) of Sri Lanka and Production index(2004-2006) of Suriname?
Offer a terse response. -13.32. In the year 1969, what is the difference between the Production index(2004-2006) in Sri Lanka and Production index(2004-2006) in Swaziland?
Give a very brief answer. 21.1. In the year 1969, what is the difference between the Production index(2004-2006) in Suriname and Production index(2004-2006) in Swaziland?
Give a very brief answer. 34.42. In the year 1970, what is the difference between the Production index(2004-2006) in Antigua and Barbuda and Production index(2004-2006) in Sri Lanka?
Provide a short and direct response. 37.51. In the year 1970, what is the difference between the Production index(2004-2006) of Antigua and Barbuda and Production index(2004-2006) of Suriname?
Give a very brief answer. 19.44. In the year 1970, what is the difference between the Production index(2004-2006) in Antigua and Barbuda and Production index(2004-2006) in Swaziland?
Give a very brief answer. 55.82. In the year 1970, what is the difference between the Production index(2004-2006) in Sri Lanka and Production index(2004-2006) in Suriname?
Keep it short and to the point. -18.07. In the year 1970, what is the difference between the Production index(2004-2006) in Sri Lanka and Production index(2004-2006) in Swaziland?
Provide a succinct answer. 18.31. In the year 1970, what is the difference between the Production index(2004-2006) of Suriname and Production index(2004-2006) of Swaziland?
Provide a short and direct response. 36.38. In the year 1971, what is the difference between the Production index(2004-2006) in Antigua and Barbuda and Production index(2004-2006) in Sri Lanka?
Provide a short and direct response. 111.64. In the year 1971, what is the difference between the Production index(2004-2006) of Antigua and Barbuda and Production index(2004-2006) of Suriname?
Your answer should be compact. 92.62. In the year 1971, what is the difference between the Production index(2004-2006) of Antigua and Barbuda and Production index(2004-2006) of Swaziland?
Provide a short and direct response. 127.8. In the year 1971, what is the difference between the Production index(2004-2006) in Sri Lanka and Production index(2004-2006) in Suriname?
Give a very brief answer. -19.02. In the year 1971, what is the difference between the Production index(2004-2006) in Sri Lanka and Production index(2004-2006) in Swaziland?
Your response must be concise. 16.16. In the year 1971, what is the difference between the Production index(2004-2006) of Suriname and Production index(2004-2006) of Swaziland?
Provide a succinct answer. 35.18. What is the ratio of the Production index(2004-2006) of Antigua and Barbuda in 1964 to that in 1965?
Give a very brief answer. 1.57. What is the ratio of the Production index(2004-2006) of Sri Lanka in 1964 to that in 1965?
Keep it short and to the point. 1.07. What is the ratio of the Production index(2004-2006) in Suriname in 1964 to that in 1965?
Provide a short and direct response. 0.78. What is the ratio of the Production index(2004-2006) in Swaziland in 1964 to that in 1965?
Make the answer very short. 0.89. What is the ratio of the Production index(2004-2006) in Antigua and Barbuda in 1964 to that in 1966?
Your response must be concise. 2.04. What is the ratio of the Production index(2004-2006) of Sri Lanka in 1964 to that in 1966?
Your answer should be compact. 1.04. What is the ratio of the Production index(2004-2006) of Suriname in 1964 to that in 1966?
Give a very brief answer. 0.73. What is the ratio of the Production index(2004-2006) of Swaziland in 1964 to that in 1966?
Your answer should be compact. 0.74. What is the ratio of the Production index(2004-2006) of Antigua and Barbuda in 1964 to that in 1967?
Offer a terse response. 2.46. What is the ratio of the Production index(2004-2006) of Sri Lanka in 1964 to that in 1967?
Provide a short and direct response. 0.94. What is the ratio of the Production index(2004-2006) in Suriname in 1964 to that in 1967?
Your answer should be very brief. 0.62. What is the ratio of the Production index(2004-2006) in Swaziland in 1964 to that in 1967?
Give a very brief answer. 0.63. What is the ratio of the Production index(2004-2006) of Antigua and Barbuda in 1964 to that in 1968?
Offer a very short reply. 3.36. What is the ratio of the Production index(2004-2006) of Sri Lanka in 1964 to that in 1968?
Provide a short and direct response. 0.9. What is the ratio of the Production index(2004-2006) in Suriname in 1964 to that in 1968?
Provide a succinct answer. 0.61. What is the ratio of the Production index(2004-2006) of Swaziland in 1964 to that in 1968?
Your answer should be compact. 0.66. What is the ratio of the Production index(2004-2006) of Antigua and Barbuda in 1964 to that in 1969?
Your response must be concise. 2.57. What is the ratio of the Production index(2004-2006) of Sri Lanka in 1964 to that in 1969?
Make the answer very short. 0.9. What is the ratio of the Production index(2004-2006) of Suriname in 1964 to that in 1969?
Your answer should be very brief. 0.63. What is the ratio of the Production index(2004-2006) in Swaziland in 1964 to that in 1969?
Your answer should be very brief. 0.61. What is the ratio of the Production index(2004-2006) in Antigua and Barbuda in 1964 to that in 1970?
Provide a succinct answer. 2.47. What is the ratio of the Production index(2004-2006) in Sri Lanka in 1964 to that in 1970?
Ensure brevity in your answer.  0.85. What is the ratio of the Production index(2004-2006) of Suriname in 1964 to that in 1970?
Your answer should be compact. 0.56. What is the ratio of the Production index(2004-2006) of Swaziland in 1964 to that in 1970?
Make the answer very short. 0.53. What is the ratio of the Production index(2004-2006) of Antigua and Barbuda in 1964 to that in 1971?
Offer a terse response. 1.44. What is the ratio of the Production index(2004-2006) of Sri Lanka in 1964 to that in 1971?
Your answer should be very brief. 0.88. What is the ratio of the Production index(2004-2006) of Suriname in 1964 to that in 1971?
Make the answer very short. 0.57. What is the ratio of the Production index(2004-2006) of Swaziland in 1964 to that in 1971?
Keep it short and to the point. 0.52. What is the ratio of the Production index(2004-2006) of Antigua and Barbuda in 1965 to that in 1966?
Your response must be concise. 1.3. What is the ratio of the Production index(2004-2006) of Sri Lanka in 1965 to that in 1966?
Keep it short and to the point. 0.97. What is the ratio of the Production index(2004-2006) of Suriname in 1965 to that in 1966?
Make the answer very short. 0.95. What is the ratio of the Production index(2004-2006) of Swaziland in 1965 to that in 1966?
Make the answer very short. 0.83. What is the ratio of the Production index(2004-2006) of Antigua and Barbuda in 1965 to that in 1967?
Your response must be concise. 1.57. What is the ratio of the Production index(2004-2006) of Sri Lanka in 1965 to that in 1967?
Make the answer very short. 0.87. What is the ratio of the Production index(2004-2006) in Suriname in 1965 to that in 1967?
Your answer should be very brief. 0.8. What is the ratio of the Production index(2004-2006) in Swaziland in 1965 to that in 1967?
Provide a succinct answer. 0.71. What is the ratio of the Production index(2004-2006) of Antigua and Barbuda in 1965 to that in 1968?
Your response must be concise. 2.14. What is the ratio of the Production index(2004-2006) of Sri Lanka in 1965 to that in 1968?
Offer a terse response. 0.84. What is the ratio of the Production index(2004-2006) of Suriname in 1965 to that in 1968?
Give a very brief answer. 0.78. What is the ratio of the Production index(2004-2006) of Swaziland in 1965 to that in 1968?
Provide a short and direct response. 0.74. What is the ratio of the Production index(2004-2006) of Antigua and Barbuda in 1965 to that in 1969?
Keep it short and to the point. 1.64. What is the ratio of the Production index(2004-2006) of Sri Lanka in 1965 to that in 1969?
Provide a short and direct response. 0.84. What is the ratio of the Production index(2004-2006) in Suriname in 1965 to that in 1969?
Give a very brief answer. 0.81. What is the ratio of the Production index(2004-2006) in Swaziland in 1965 to that in 1969?
Give a very brief answer. 0.69. What is the ratio of the Production index(2004-2006) in Antigua and Barbuda in 1965 to that in 1970?
Your answer should be compact. 1.57. What is the ratio of the Production index(2004-2006) of Sri Lanka in 1965 to that in 1970?
Provide a succinct answer. 0.8. What is the ratio of the Production index(2004-2006) of Suriname in 1965 to that in 1970?
Your answer should be compact. 0.73. What is the ratio of the Production index(2004-2006) in Swaziland in 1965 to that in 1970?
Make the answer very short. 0.59. What is the ratio of the Production index(2004-2006) of Antigua and Barbuda in 1965 to that in 1971?
Provide a succinct answer. 0.92. What is the ratio of the Production index(2004-2006) of Sri Lanka in 1965 to that in 1971?
Your response must be concise. 0.82. What is the ratio of the Production index(2004-2006) of Suriname in 1965 to that in 1971?
Keep it short and to the point. 0.73. What is the ratio of the Production index(2004-2006) in Swaziland in 1965 to that in 1971?
Give a very brief answer. 0.59. What is the ratio of the Production index(2004-2006) of Antigua and Barbuda in 1966 to that in 1967?
Make the answer very short. 1.21. What is the ratio of the Production index(2004-2006) in Sri Lanka in 1966 to that in 1967?
Make the answer very short. 0.9. What is the ratio of the Production index(2004-2006) of Suriname in 1966 to that in 1967?
Provide a short and direct response. 0.85. What is the ratio of the Production index(2004-2006) in Swaziland in 1966 to that in 1967?
Ensure brevity in your answer.  0.85. What is the ratio of the Production index(2004-2006) of Antigua and Barbuda in 1966 to that in 1968?
Your response must be concise. 1.65. What is the ratio of the Production index(2004-2006) of Sri Lanka in 1966 to that in 1968?
Provide a short and direct response. 0.86. What is the ratio of the Production index(2004-2006) of Suriname in 1966 to that in 1968?
Your answer should be compact. 0.83. What is the ratio of the Production index(2004-2006) in Swaziland in 1966 to that in 1968?
Make the answer very short. 0.89. What is the ratio of the Production index(2004-2006) of Antigua and Barbuda in 1966 to that in 1969?
Offer a very short reply. 1.26. What is the ratio of the Production index(2004-2006) of Sri Lanka in 1966 to that in 1969?
Your answer should be very brief. 0.87. What is the ratio of the Production index(2004-2006) of Suriname in 1966 to that in 1969?
Your answer should be compact. 0.85. What is the ratio of the Production index(2004-2006) of Swaziland in 1966 to that in 1969?
Provide a short and direct response. 0.82. What is the ratio of the Production index(2004-2006) of Antigua and Barbuda in 1966 to that in 1970?
Offer a very short reply. 1.21. What is the ratio of the Production index(2004-2006) in Sri Lanka in 1966 to that in 1970?
Your answer should be very brief. 0.82. What is the ratio of the Production index(2004-2006) in Suriname in 1966 to that in 1970?
Provide a short and direct response. 0.77. What is the ratio of the Production index(2004-2006) in Swaziland in 1966 to that in 1970?
Ensure brevity in your answer.  0.71. What is the ratio of the Production index(2004-2006) in Antigua and Barbuda in 1966 to that in 1971?
Ensure brevity in your answer.  0.71. What is the ratio of the Production index(2004-2006) of Sri Lanka in 1966 to that in 1971?
Your answer should be very brief. 0.84. What is the ratio of the Production index(2004-2006) of Suriname in 1966 to that in 1971?
Offer a very short reply. 0.78. What is the ratio of the Production index(2004-2006) in Swaziland in 1966 to that in 1971?
Make the answer very short. 0.7. What is the ratio of the Production index(2004-2006) in Antigua and Barbuda in 1967 to that in 1968?
Give a very brief answer. 1.37. What is the ratio of the Production index(2004-2006) of Sri Lanka in 1967 to that in 1968?
Offer a terse response. 0.96. What is the ratio of the Production index(2004-2006) in Suriname in 1967 to that in 1968?
Provide a short and direct response. 0.98. What is the ratio of the Production index(2004-2006) in Swaziland in 1967 to that in 1968?
Ensure brevity in your answer.  1.05. What is the ratio of the Production index(2004-2006) of Antigua and Barbuda in 1967 to that in 1969?
Your answer should be compact. 1.05. What is the ratio of the Production index(2004-2006) of Sri Lanka in 1967 to that in 1969?
Give a very brief answer. 0.96. What is the ratio of the Production index(2004-2006) of Suriname in 1967 to that in 1969?
Provide a succinct answer. 1.01. What is the ratio of the Production index(2004-2006) of Swaziland in 1967 to that in 1969?
Make the answer very short. 0.97. What is the ratio of the Production index(2004-2006) in Antigua and Barbuda in 1967 to that in 1970?
Keep it short and to the point. 1.01. What is the ratio of the Production index(2004-2006) of Sri Lanka in 1967 to that in 1970?
Offer a terse response. 0.91. What is the ratio of the Production index(2004-2006) in Suriname in 1967 to that in 1970?
Make the answer very short. 0.91. What is the ratio of the Production index(2004-2006) in Swaziland in 1967 to that in 1970?
Offer a very short reply. 0.84. What is the ratio of the Production index(2004-2006) in Antigua and Barbuda in 1967 to that in 1971?
Keep it short and to the point. 0.59. What is the ratio of the Production index(2004-2006) of Sri Lanka in 1967 to that in 1971?
Give a very brief answer. 0.94. What is the ratio of the Production index(2004-2006) of Suriname in 1967 to that in 1971?
Give a very brief answer. 0.92. What is the ratio of the Production index(2004-2006) of Swaziland in 1967 to that in 1971?
Give a very brief answer. 0.83. What is the ratio of the Production index(2004-2006) in Antigua and Barbuda in 1968 to that in 1969?
Keep it short and to the point. 0.76. What is the ratio of the Production index(2004-2006) of Suriname in 1968 to that in 1969?
Ensure brevity in your answer.  1.03. What is the ratio of the Production index(2004-2006) of Swaziland in 1968 to that in 1969?
Make the answer very short. 0.92. What is the ratio of the Production index(2004-2006) in Antigua and Barbuda in 1968 to that in 1970?
Provide a succinct answer. 0.73. What is the ratio of the Production index(2004-2006) in Sri Lanka in 1968 to that in 1970?
Your response must be concise. 0.95. What is the ratio of the Production index(2004-2006) in Suriname in 1968 to that in 1970?
Provide a short and direct response. 0.93. What is the ratio of the Production index(2004-2006) of Swaziland in 1968 to that in 1970?
Ensure brevity in your answer.  0.8. What is the ratio of the Production index(2004-2006) of Antigua and Barbuda in 1968 to that in 1971?
Offer a terse response. 0.43. What is the ratio of the Production index(2004-2006) of Sri Lanka in 1968 to that in 1971?
Your response must be concise. 0.97. What is the ratio of the Production index(2004-2006) of Suriname in 1968 to that in 1971?
Your response must be concise. 0.94. What is the ratio of the Production index(2004-2006) of Swaziland in 1968 to that in 1971?
Your answer should be very brief. 0.79. What is the ratio of the Production index(2004-2006) of Antigua and Barbuda in 1969 to that in 1970?
Your response must be concise. 0.96. What is the ratio of the Production index(2004-2006) of Sri Lanka in 1969 to that in 1970?
Provide a short and direct response. 0.95. What is the ratio of the Production index(2004-2006) in Suriname in 1969 to that in 1970?
Make the answer very short. 0.9. What is the ratio of the Production index(2004-2006) in Swaziland in 1969 to that in 1970?
Provide a short and direct response. 0.86. What is the ratio of the Production index(2004-2006) in Antigua and Barbuda in 1969 to that in 1971?
Provide a short and direct response. 0.56. What is the ratio of the Production index(2004-2006) in Sri Lanka in 1969 to that in 1971?
Offer a terse response. 0.97. What is the ratio of the Production index(2004-2006) in Suriname in 1969 to that in 1971?
Make the answer very short. 0.91. What is the ratio of the Production index(2004-2006) in Swaziland in 1969 to that in 1971?
Offer a very short reply. 0.85. What is the ratio of the Production index(2004-2006) of Antigua and Barbuda in 1970 to that in 1971?
Offer a terse response. 0.58. What is the ratio of the Production index(2004-2006) of Sri Lanka in 1970 to that in 1971?
Your response must be concise. 1.03. What is the ratio of the Production index(2004-2006) of Suriname in 1970 to that in 1971?
Offer a terse response. 1.01. What is the ratio of the Production index(2004-2006) in Swaziland in 1970 to that in 1971?
Your answer should be very brief. 0.99. What is the difference between the highest and the second highest Production index(2004-2006) in Antigua and Barbuda?
Provide a short and direct response. 77.55. What is the difference between the highest and the second highest Production index(2004-2006) of Sri Lanka?
Make the answer very short. 1.68. What is the difference between the highest and the second highest Production index(2004-2006) in Suriname?
Make the answer very short. 0.73. What is the difference between the highest and the second highest Production index(2004-2006) in Swaziland?
Give a very brief answer. 0.47. What is the difference between the highest and the lowest Production index(2004-2006) in Antigua and Barbuda?
Your answer should be compact. 177.12. What is the difference between the highest and the lowest Production index(2004-2006) of Suriname?
Your answer should be compact. 36.04. What is the difference between the highest and the lowest Production index(2004-2006) of Swaziland?
Provide a short and direct response. 22.28. 